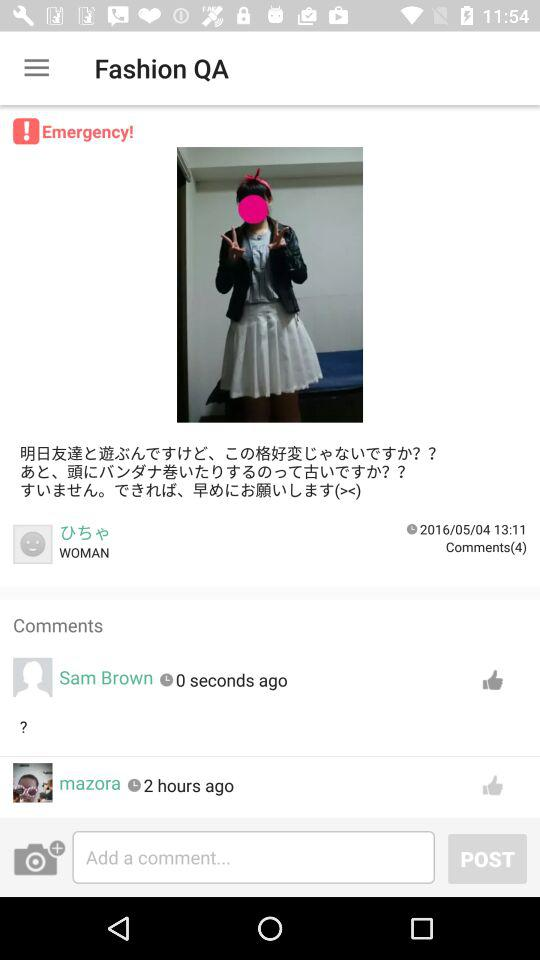How long ago did Mazora comment? Mazora commented 2 hours ago. 